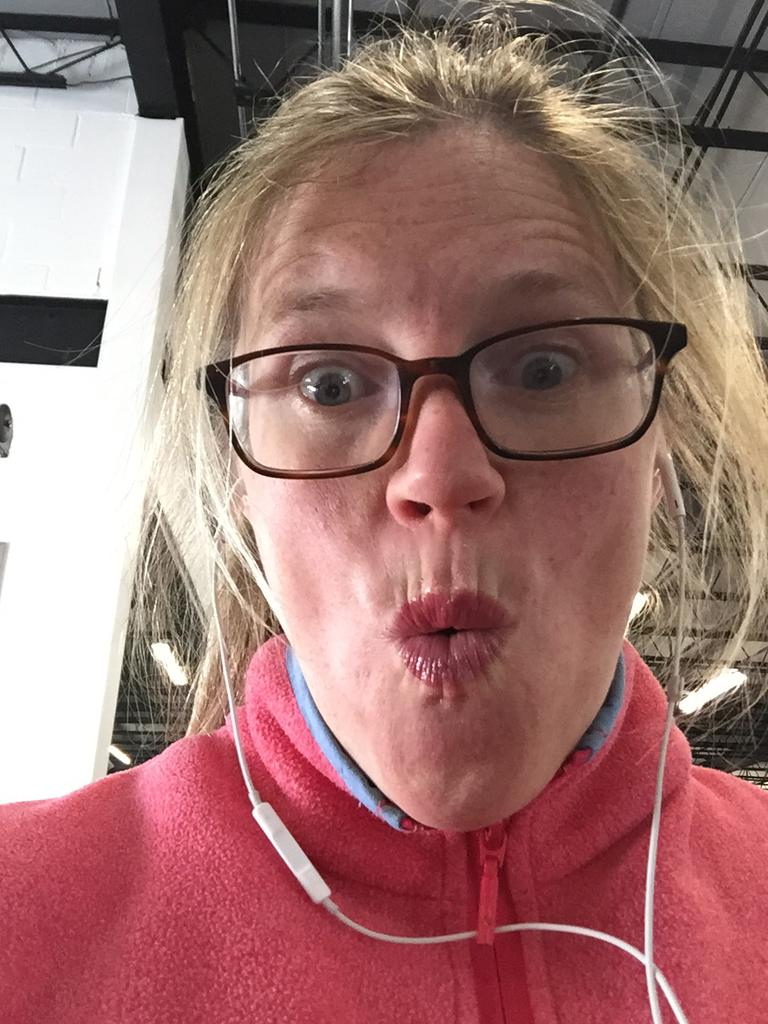Who is present in the image? There is a woman in the image. What accessory is the woman wearing in the image? The woman is wearing spectacles. What type of yam is the woman holding in the image? There is no yam present in the image; the woman is wearing spectacles. Is the woman writing in a notebook in the image? There is: There is no notebook present in the image. 